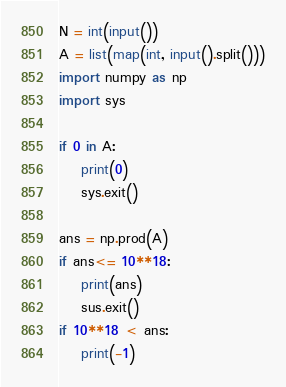<code> <loc_0><loc_0><loc_500><loc_500><_Python_>N = int(input())
A = list(map(int, input().split()))
import numpy as np
import sys

if 0 in A:
    print(0)
    sys.exit()

ans = np.prod(A)
if ans<= 10**18:
    print(ans)
    sus.exit()
if 10**18 < ans:
    print(-1)
</code> 